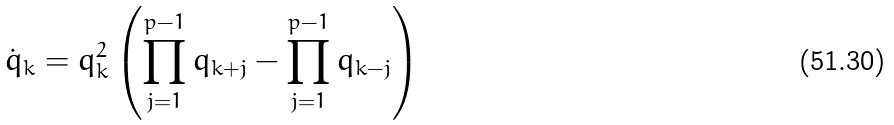Convert formula to latex. <formula><loc_0><loc_0><loc_500><loc_500>\dot { q } _ { k } = q _ { k } ^ { 2 } \left ( \prod _ { j = 1 } ^ { p - 1 } q _ { k + j } - \prod _ { j = 1 } ^ { p - 1 } q _ { k - j } \right )</formula> 